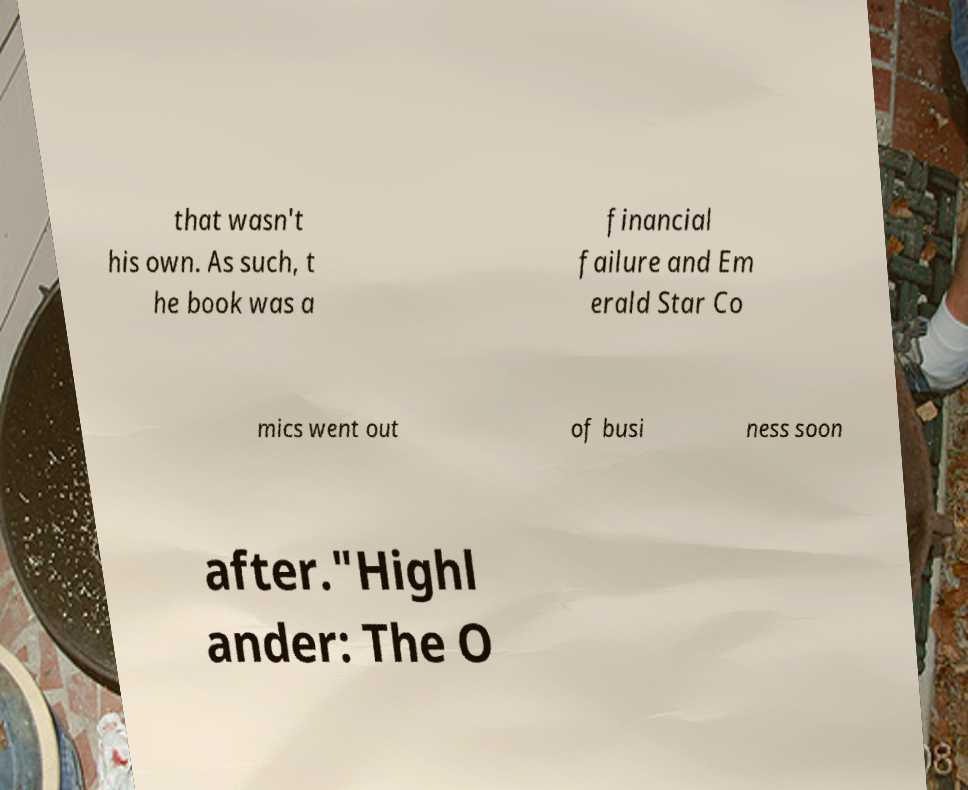Can you read and provide the text displayed in the image?This photo seems to have some interesting text. Can you extract and type it out for me? that wasn't his own. As such, t he book was a financial failure and Em erald Star Co mics went out of busi ness soon after."Highl ander: The O 